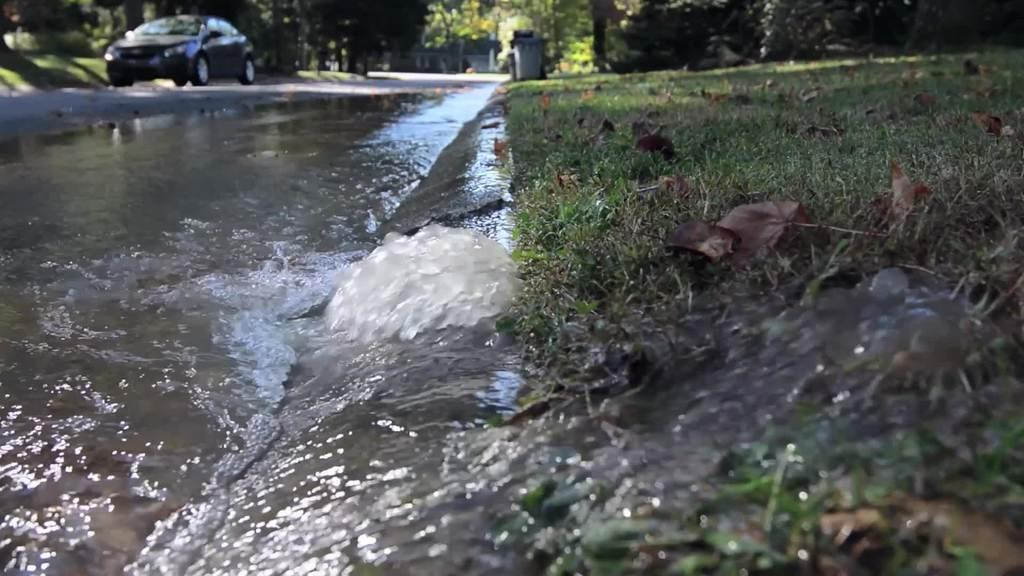What type of vegetation can be seen in the image? There are trees in the image. What type of structures are present in the image? There are sheds in the image. What type of containers are visible in the image? There are bins in the image. What is on the road in the image? There is a vehicle on the road in the image. What can be seen at the bottom of the image? There is water and ground visible at the bottom of the image. What type of event is taking place in the image? There is no event taking place in the image; it is a scene featuring trees, sheds, bins, a vehicle, water, and ground. What type of clothing is visible on the trees in the image? There is no clothing visible on the trees in the image; they are simply trees. 